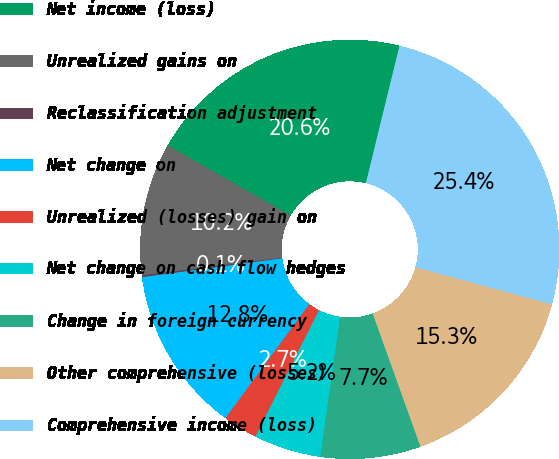<chart> <loc_0><loc_0><loc_500><loc_500><pie_chart><fcel>Net income (loss)<fcel>Unrealized gains on<fcel>Reclassification adjustment<fcel>Net change on<fcel>Unrealized (losses) gain on<fcel>Net change on cash flow hedges<fcel>Change in foreign currency<fcel>Other comprehensive (losses)<fcel>Comprehensive income (loss)<nl><fcel>20.57%<fcel>10.24%<fcel>0.14%<fcel>12.77%<fcel>2.67%<fcel>5.19%<fcel>7.72%<fcel>15.3%<fcel>25.4%<nl></chart> 